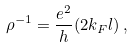<formula> <loc_0><loc_0><loc_500><loc_500>\rho ^ { - 1 } = \frac { e ^ { 2 } } { h } ( 2 k _ { F } l ) \, ,</formula> 